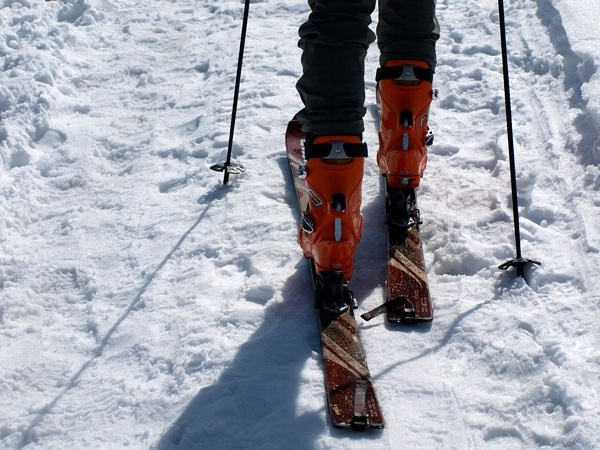Describe the objects in this image and their specific colors. I can see people in lightgray, black, maroon, gray, and brown tones and skis in lightgray, black, gray, and maroon tones in this image. 